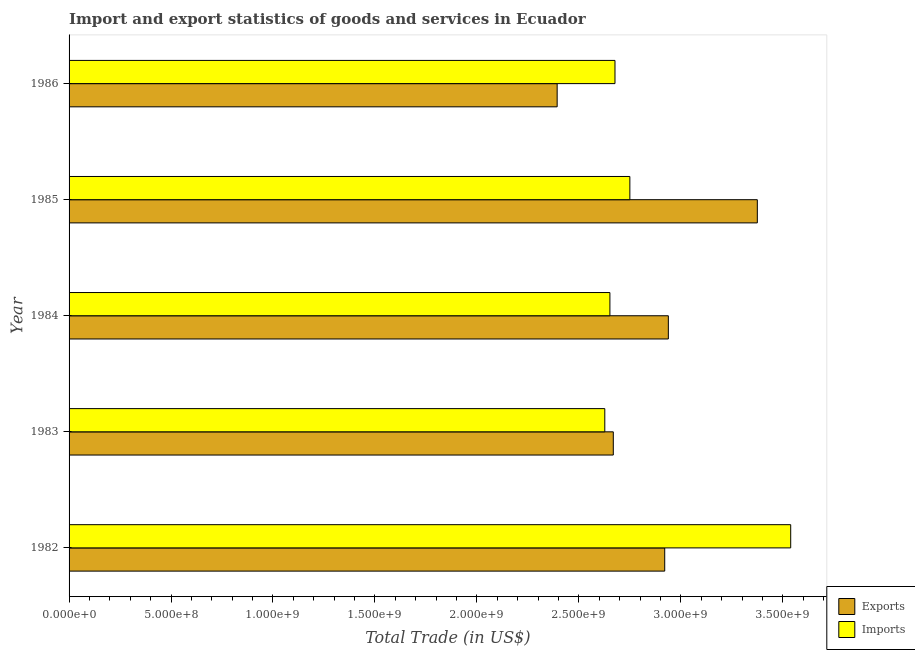How many bars are there on the 1st tick from the top?
Provide a short and direct response. 2. How many bars are there on the 3rd tick from the bottom?
Offer a terse response. 2. What is the imports of goods and services in 1982?
Provide a short and direct response. 3.54e+09. Across all years, what is the maximum export of goods and services?
Ensure brevity in your answer.  3.38e+09. Across all years, what is the minimum imports of goods and services?
Offer a terse response. 2.63e+09. In which year was the export of goods and services maximum?
Ensure brevity in your answer.  1985. What is the total imports of goods and services in the graph?
Offer a terse response. 1.42e+1. What is the difference between the export of goods and services in 1982 and that in 1983?
Your answer should be very brief. 2.52e+08. What is the difference between the export of goods and services in 1984 and the imports of goods and services in 1983?
Provide a short and direct response. 3.12e+08. What is the average export of goods and services per year?
Offer a terse response. 2.86e+09. In the year 1984, what is the difference between the export of goods and services and imports of goods and services?
Keep it short and to the point. 2.87e+08. What is the ratio of the imports of goods and services in 1983 to that in 1985?
Give a very brief answer. 0.95. Is the export of goods and services in 1983 less than that in 1986?
Give a very brief answer. No. What is the difference between the highest and the second highest export of goods and services?
Make the answer very short. 4.36e+08. What is the difference between the highest and the lowest export of goods and services?
Your answer should be very brief. 9.82e+08. What does the 2nd bar from the top in 1986 represents?
Offer a terse response. Exports. What does the 2nd bar from the bottom in 1983 represents?
Give a very brief answer. Imports. How many bars are there?
Your response must be concise. 10. Are all the bars in the graph horizontal?
Ensure brevity in your answer.  Yes. What is the difference between two consecutive major ticks on the X-axis?
Your answer should be compact. 5.00e+08. Are the values on the major ticks of X-axis written in scientific E-notation?
Offer a terse response. Yes. Does the graph contain grids?
Give a very brief answer. No. How many legend labels are there?
Offer a terse response. 2. How are the legend labels stacked?
Give a very brief answer. Vertical. What is the title of the graph?
Provide a succinct answer. Import and export statistics of goods and services in Ecuador. Does "Official aid received" appear as one of the legend labels in the graph?
Provide a succinct answer. No. What is the label or title of the X-axis?
Your answer should be very brief. Total Trade (in US$). What is the label or title of the Y-axis?
Make the answer very short. Year. What is the Total Trade (in US$) in Exports in 1982?
Your response must be concise. 2.92e+09. What is the Total Trade (in US$) in Imports in 1982?
Offer a very short reply. 3.54e+09. What is the Total Trade (in US$) of Exports in 1983?
Your answer should be compact. 2.67e+09. What is the Total Trade (in US$) of Imports in 1983?
Provide a short and direct response. 2.63e+09. What is the Total Trade (in US$) in Exports in 1984?
Provide a succinct answer. 2.94e+09. What is the Total Trade (in US$) of Imports in 1984?
Provide a short and direct response. 2.65e+09. What is the Total Trade (in US$) of Exports in 1985?
Provide a succinct answer. 3.38e+09. What is the Total Trade (in US$) in Imports in 1985?
Ensure brevity in your answer.  2.75e+09. What is the Total Trade (in US$) of Exports in 1986?
Give a very brief answer. 2.39e+09. What is the Total Trade (in US$) of Imports in 1986?
Offer a terse response. 2.68e+09. Across all years, what is the maximum Total Trade (in US$) of Exports?
Offer a very short reply. 3.38e+09. Across all years, what is the maximum Total Trade (in US$) of Imports?
Provide a short and direct response. 3.54e+09. Across all years, what is the minimum Total Trade (in US$) in Exports?
Ensure brevity in your answer.  2.39e+09. Across all years, what is the minimum Total Trade (in US$) of Imports?
Make the answer very short. 2.63e+09. What is the total Total Trade (in US$) in Exports in the graph?
Provide a short and direct response. 1.43e+1. What is the total Total Trade (in US$) of Imports in the graph?
Your answer should be compact. 1.42e+1. What is the difference between the Total Trade (in US$) of Exports in 1982 and that in 1983?
Give a very brief answer. 2.52e+08. What is the difference between the Total Trade (in US$) of Imports in 1982 and that in 1983?
Offer a very short reply. 9.12e+08. What is the difference between the Total Trade (in US$) in Exports in 1982 and that in 1984?
Keep it short and to the point. -1.78e+07. What is the difference between the Total Trade (in US$) of Imports in 1982 and that in 1984?
Your answer should be compact. 8.87e+08. What is the difference between the Total Trade (in US$) of Exports in 1982 and that in 1985?
Your answer should be very brief. -4.54e+08. What is the difference between the Total Trade (in US$) of Imports in 1982 and that in 1985?
Provide a short and direct response. 7.89e+08. What is the difference between the Total Trade (in US$) in Exports in 1982 and that in 1986?
Make the answer very short. 5.28e+08. What is the difference between the Total Trade (in US$) in Imports in 1982 and that in 1986?
Give a very brief answer. 8.62e+08. What is the difference between the Total Trade (in US$) of Exports in 1983 and that in 1984?
Ensure brevity in your answer.  -2.70e+08. What is the difference between the Total Trade (in US$) in Imports in 1983 and that in 1984?
Keep it short and to the point. -2.51e+07. What is the difference between the Total Trade (in US$) of Exports in 1983 and that in 1985?
Offer a terse response. -7.06e+08. What is the difference between the Total Trade (in US$) of Imports in 1983 and that in 1985?
Make the answer very short. -1.23e+08. What is the difference between the Total Trade (in US$) of Exports in 1983 and that in 1986?
Provide a succinct answer. 2.75e+08. What is the difference between the Total Trade (in US$) of Imports in 1983 and that in 1986?
Offer a very short reply. -5.00e+07. What is the difference between the Total Trade (in US$) in Exports in 1984 and that in 1985?
Ensure brevity in your answer.  -4.36e+08. What is the difference between the Total Trade (in US$) of Imports in 1984 and that in 1985?
Your response must be concise. -9.78e+07. What is the difference between the Total Trade (in US$) in Exports in 1984 and that in 1986?
Ensure brevity in your answer.  5.45e+08. What is the difference between the Total Trade (in US$) of Imports in 1984 and that in 1986?
Ensure brevity in your answer.  -2.49e+07. What is the difference between the Total Trade (in US$) in Exports in 1985 and that in 1986?
Offer a terse response. 9.82e+08. What is the difference between the Total Trade (in US$) of Imports in 1985 and that in 1986?
Offer a terse response. 7.29e+07. What is the difference between the Total Trade (in US$) of Exports in 1982 and the Total Trade (in US$) of Imports in 1983?
Give a very brief answer. 2.94e+08. What is the difference between the Total Trade (in US$) of Exports in 1982 and the Total Trade (in US$) of Imports in 1984?
Your response must be concise. 2.69e+08. What is the difference between the Total Trade (in US$) in Exports in 1982 and the Total Trade (in US$) in Imports in 1985?
Your response must be concise. 1.71e+08. What is the difference between the Total Trade (in US$) in Exports in 1982 and the Total Trade (in US$) in Imports in 1986?
Provide a short and direct response. 2.44e+08. What is the difference between the Total Trade (in US$) in Exports in 1983 and the Total Trade (in US$) in Imports in 1984?
Provide a succinct answer. 1.67e+07. What is the difference between the Total Trade (in US$) in Exports in 1983 and the Total Trade (in US$) in Imports in 1985?
Your response must be concise. -8.12e+07. What is the difference between the Total Trade (in US$) in Exports in 1983 and the Total Trade (in US$) in Imports in 1986?
Offer a terse response. -8.24e+06. What is the difference between the Total Trade (in US$) in Exports in 1984 and the Total Trade (in US$) in Imports in 1985?
Provide a short and direct response. 1.89e+08. What is the difference between the Total Trade (in US$) in Exports in 1984 and the Total Trade (in US$) in Imports in 1986?
Provide a succinct answer. 2.62e+08. What is the difference between the Total Trade (in US$) of Exports in 1985 and the Total Trade (in US$) of Imports in 1986?
Ensure brevity in your answer.  6.98e+08. What is the average Total Trade (in US$) in Exports per year?
Your answer should be very brief. 2.86e+09. What is the average Total Trade (in US$) in Imports per year?
Provide a succinct answer. 2.85e+09. In the year 1982, what is the difference between the Total Trade (in US$) in Exports and Total Trade (in US$) in Imports?
Offer a very short reply. -6.18e+08. In the year 1983, what is the difference between the Total Trade (in US$) of Exports and Total Trade (in US$) of Imports?
Ensure brevity in your answer.  4.17e+07. In the year 1984, what is the difference between the Total Trade (in US$) in Exports and Total Trade (in US$) in Imports?
Provide a short and direct response. 2.87e+08. In the year 1985, what is the difference between the Total Trade (in US$) of Exports and Total Trade (in US$) of Imports?
Your response must be concise. 6.25e+08. In the year 1986, what is the difference between the Total Trade (in US$) in Exports and Total Trade (in US$) in Imports?
Your response must be concise. -2.84e+08. What is the ratio of the Total Trade (in US$) in Exports in 1982 to that in 1983?
Give a very brief answer. 1.09. What is the ratio of the Total Trade (in US$) in Imports in 1982 to that in 1983?
Give a very brief answer. 1.35. What is the ratio of the Total Trade (in US$) in Imports in 1982 to that in 1984?
Offer a terse response. 1.33. What is the ratio of the Total Trade (in US$) of Exports in 1982 to that in 1985?
Your answer should be very brief. 0.87. What is the ratio of the Total Trade (in US$) of Imports in 1982 to that in 1985?
Your answer should be very brief. 1.29. What is the ratio of the Total Trade (in US$) of Exports in 1982 to that in 1986?
Make the answer very short. 1.22. What is the ratio of the Total Trade (in US$) of Imports in 1982 to that in 1986?
Provide a short and direct response. 1.32. What is the ratio of the Total Trade (in US$) of Exports in 1983 to that in 1984?
Offer a very short reply. 0.91. What is the ratio of the Total Trade (in US$) in Imports in 1983 to that in 1984?
Provide a short and direct response. 0.99. What is the ratio of the Total Trade (in US$) in Exports in 1983 to that in 1985?
Your response must be concise. 0.79. What is the ratio of the Total Trade (in US$) of Imports in 1983 to that in 1985?
Make the answer very short. 0.96. What is the ratio of the Total Trade (in US$) in Exports in 1983 to that in 1986?
Make the answer very short. 1.11. What is the ratio of the Total Trade (in US$) of Imports in 1983 to that in 1986?
Provide a succinct answer. 0.98. What is the ratio of the Total Trade (in US$) in Exports in 1984 to that in 1985?
Keep it short and to the point. 0.87. What is the ratio of the Total Trade (in US$) of Imports in 1984 to that in 1985?
Your response must be concise. 0.96. What is the ratio of the Total Trade (in US$) in Exports in 1984 to that in 1986?
Provide a short and direct response. 1.23. What is the ratio of the Total Trade (in US$) of Imports in 1984 to that in 1986?
Offer a terse response. 0.99. What is the ratio of the Total Trade (in US$) of Exports in 1985 to that in 1986?
Provide a succinct answer. 1.41. What is the ratio of the Total Trade (in US$) of Imports in 1985 to that in 1986?
Your response must be concise. 1.03. What is the difference between the highest and the second highest Total Trade (in US$) in Exports?
Keep it short and to the point. 4.36e+08. What is the difference between the highest and the second highest Total Trade (in US$) in Imports?
Offer a very short reply. 7.89e+08. What is the difference between the highest and the lowest Total Trade (in US$) of Exports?
Provide a succinct answer. 9.82e+08. What is the difference between the highest and the lowest Total Trade (in US$) in Imports?
Keep it short and to the point. 9.12e+08. 